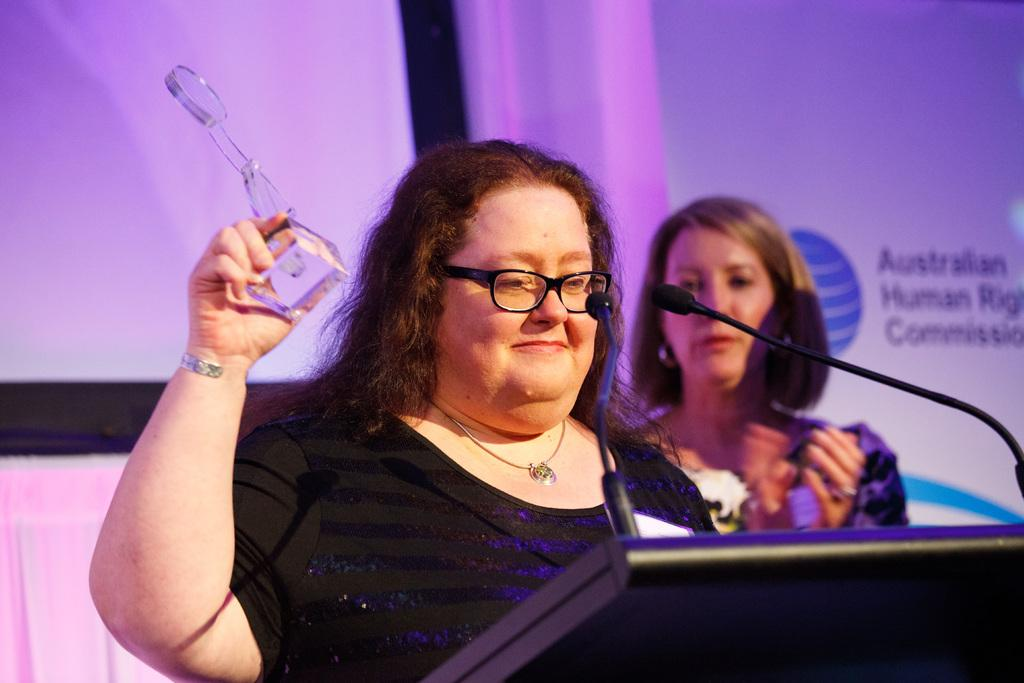How many women are present in the image? There are two women in the image. What is the position of one of the women in the image? One woman is standing in front of a podium. What is the woman holding in her hand? The woman is holding an award in her hand. What can be seen in the background of the image? There is a poster in the background of the image. What is written on the poster? Text is written on the poster. Can you see an owl perched on the podium in the image? No, there is no owl present in the image. What holiday is being celebrated in the image? There is no indication of a holiday being celebrated in the image. 